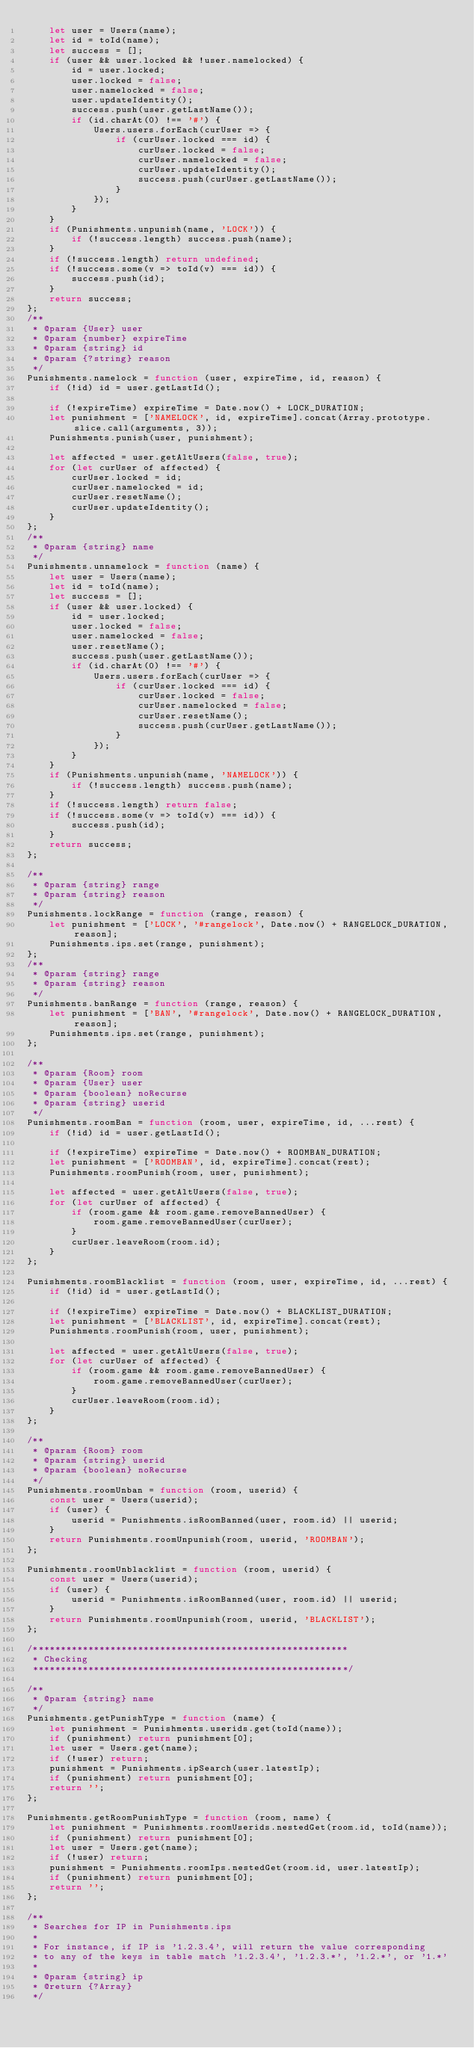Convert code to text. <code><loc_0><loc_0><loc_500><loc_500><_JavaScript_>	let user = Users(name);
	let id = toId(name);
	let success = [];
	if (user && user.locked && !user.namelocked) {
		id = user.locked;
		user.locked = false;
		user.namelocked = false;
		user.updateIdentity();
		success.push(user.getLastName());
		if (id.charAt(0) !== '#') {
			Users.users.forEach(curUser => {
				if (curUser.locked === id) {
					curUser.locked = false;
					curUser.namelocked = false;
					curUser.updateIdentity();
					success.push(curUser.getLastName());
				}
			});
		}
	}
	if (Punishments.unpunish(name, 'LOCK')) {
		if (!success.length) success.push(name);
	}
	if (!success.length) return undefined;
	if (!success.some(v => toId(v) === id)) {
		success.push(id);
	}
	return success;
};
/**
 * @param {User} user
 * @param {number} expireTime
 * @param {string} id
 * @param {?string} reason
 */
Punishments.namelock = function (user, expireTime, id, reason) {
	if (!id) id = user.getLastId();

	if (!expireTime) expireTime = Date.now() + LOCK_DURATION;
	let punishment = ['NAMELOCK', id, expireTime].concat(Array.prototype.slice.call(arguments, 3));
	Punishments.punish(user, punishment);

	let affected = user.getAltUsers(false, true);
	for (let curUser of affected) {
		curUser.locked = id;
		curUser.namelocked = id;
		curUser.resetName();
		curUser.updateIdentity();
	}
};
/**
 * @param {string} name
 */
Punishments.unnamelock = function (name) {
	let user = Users(name);
	let id = toId(name);
	let success = [];
	if (user && user.locked) {
		id = user.locked;
		user.locked = false;
		user.namelocked = false;
		user.resetName();
		success.push(user.getLastName());
		if (id.charAt(0) !== '#') {
			Users.users.forEach(curUser => {
				if (curUser.locked === id) {
					curUser.locked = false;
					curUser.namelocked = false;
					curUser.resetName();
					success.push(curUser.getLastName());
				}
			});
		}
	}
	if (Punishments.unpunish(name, 'NAMELOCK')) {
		if (!success.length) success.push(name);
	}
	if (!success.length) return false;
	if (!success.some(v => toId(v) === id)) {
		success.push(id);
	}
	return success;
};

/**
 * @param {string} range
 * @param {string} reason
 */
Punishments.lockRange = function (range, reason) {
	let punishment = ['LOCK', '#rangelock', Date.now() + RANGELOCK_DURATION, reason];
	Punishments.ips.set(range, punishment);
};
/**
 * @param {string} range
 * @param {string} reason
 */
Punishments.banRange = function (range, reason) {
	let punishment = ['BAN', '#rangelock', Date.now() + RANGELOCK_DURATION, reason];
	Punishments.ips.set(range, punishment);
};

/**
 * @param {Room} room
 * @param {User} user
 * @param {boolean} noRecurse
 * @param {string} userid
 */
Punishments.roomBan = function (room, user, expireTime, id, ...rest) {
	if (!id) id = user.getLastId();

	if (!expireTime) expireTime = Date.now() + ROOMBAN_DURATION;
	let punishment = ['ROOMBAN', id, expireTime].concat(rest);
	Punishments.roomPunish(room, user, punishment);

	let affected = user.getAltUsers(false, true);
	for (let curUser of affected) {
		if (room.game && room.game.removeBannedUser) {
			room.game.removeBannedUser(curUser);
		}
		curUser.leaveRoom(room.id);
	}
};

Punishments.roomBlacklist = function (room, user, expireTime, id, ...rest) {
	if (!id) id = user.getLastId();

	if (!expireTime) expireTime = Date.now() + BLACKLIST_DURATION;
	let punishment = ['BLACKLIST', id, expireTime].concat(rest);
	Punishments.roomPunish(room, user, punishment);

	let affected = user.getAltUsers(false, true);
	for (let curUser of affected) {
		if (room.game && room.game.removeBannedUser) {
			room.game.removeBannedUser(curUser);
		}
		curUser.leaveRoom(room.id);
	}
};

/**
 * @param {Room} room
 * @param {string} userid
 * @param {boolean} noRecurse
 */
Punishments.roomUnban = function (room, userid) {
	const user = Users(userid);
	if (user) {
		userid = Punishments.isRoomBanned(user, room.id) || userid;
	}
	return Punishments.roomUnpunish(room, userid, 'ROOMBAN');
};

Punishments.roomUnblacklist = function (room, userid) {
	const user = Users(userid);
	if (user) {
		userid = Punishments.isRoomBanned(user, room.id) || userid;
	}
	return Punishments.roomUnpunish(room, userid, 'BLACKLIST');
};

/*********************************************************
 * Checking
 *********************************************************/

/**
 * @param {string} name
 */
Punishments.getPunishType = function (name) {
	let punishment = Punishments.userids.get(toId(name));
	if (punishment) return punishment[0];
	let user = Users.get(name);
	if (!user) return;
	punishment = Punishments.ipSearch(user.latestIp);
	if (punishment) return punishment[0];
	return '';
};

Punishments.getRoomPunishType = function (room, name) {
	let punishment = Punishments.roomUserids.nestedGet(room.id, toId(name));
	if (punishment) return punishment[0];
	let user = Users.get(name);
	if (!user) return;
	punishment = Punishments.roomIps.nestedGet(room.id, user.latestIp);
	if (punishment) return punishment[0];
	return '';
};

/**
 * Searches for IP in Punishments.ips
 *
 * For instance, if IP is '1.2.3.4', will return the value corresponding
 * to any of the keys in table match '1.2.3.4', '1.2.3.*', '1.2.*', or '1.*'
 *
 * @param {string} ip
 * @return {?Array}
 */</code> 